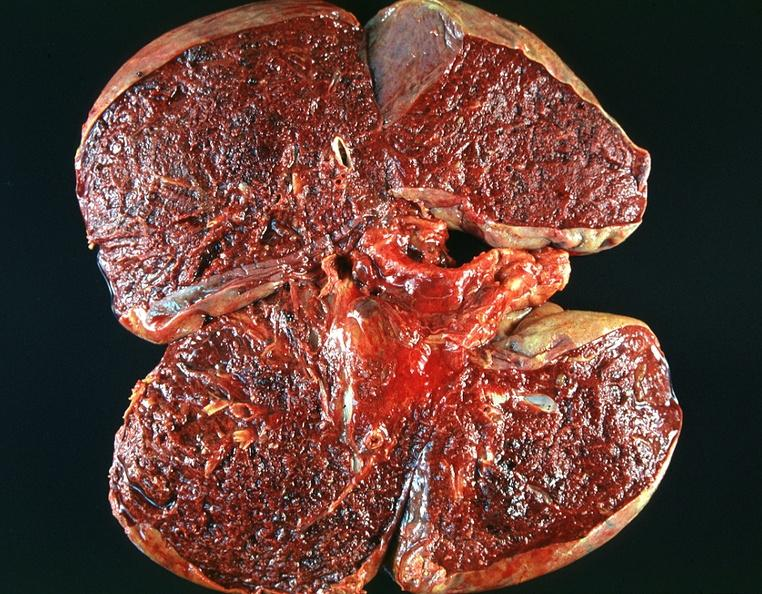what is present?
Answer the question using a single word or phrase. Respiratory 